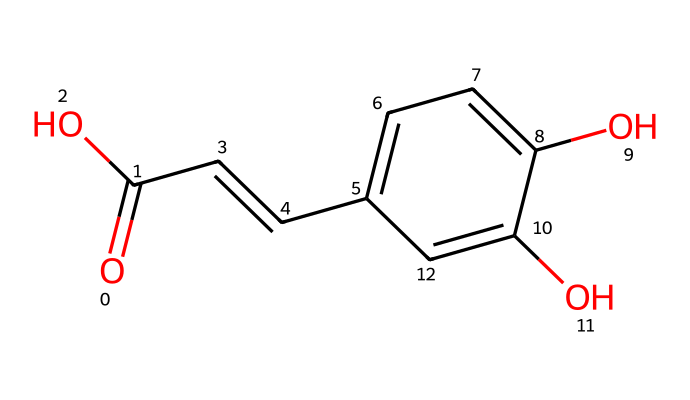What is the molecular formula of caffeic acid? To determine the molecular formula from the SMILES notation, first identify the atoms represented. The structure includes 9 carbon (C) atoms, 10 hydrogen (H) atoms, and 4 oxygen (O) atoms, thus the formula is C9H10O4.
Answer: C9H10O4 How many hydroxyl (-OH) groups are present in this structure? In the SMILES representation, the 'O' that is part of the '-OH' groups can be counted; there are two such groups attached to the benzene ring, indicated by 'c' before 'O'.
Answer: 2 Is caffeic acid a saturated or unsaturated compound? By analyzing the presence of double bonds in the structure, particularly the 'C=C' in the SMILES, it indicates that comes the existence of unsaturation in the molecule.
Answer: unsaturated What type of compound does caffeic acid belong to? The core structure features a benzene ring and carboxylic acid group, indicating it is a phenolic compound classified as a phenolic acid because of the carboxylic acid attached to the aromatic ring.
Answer: phenolic acid What is the number of rings in the caffeic acid structure? Observing the SMILES notation shows a single ring structure, specifically the aromatic benzene ring denoted by 'c1ccc'; thus, the molecule contains one ring.
Answer: 1 How many double bonds are present in caffeic acid? In the structure, there’s one double bond between carbon atoms indicated by 'C=C' and another one in the carboxylic acid functional group (C=O). Combining both gives a total of two double bonds.
Answer: 2 